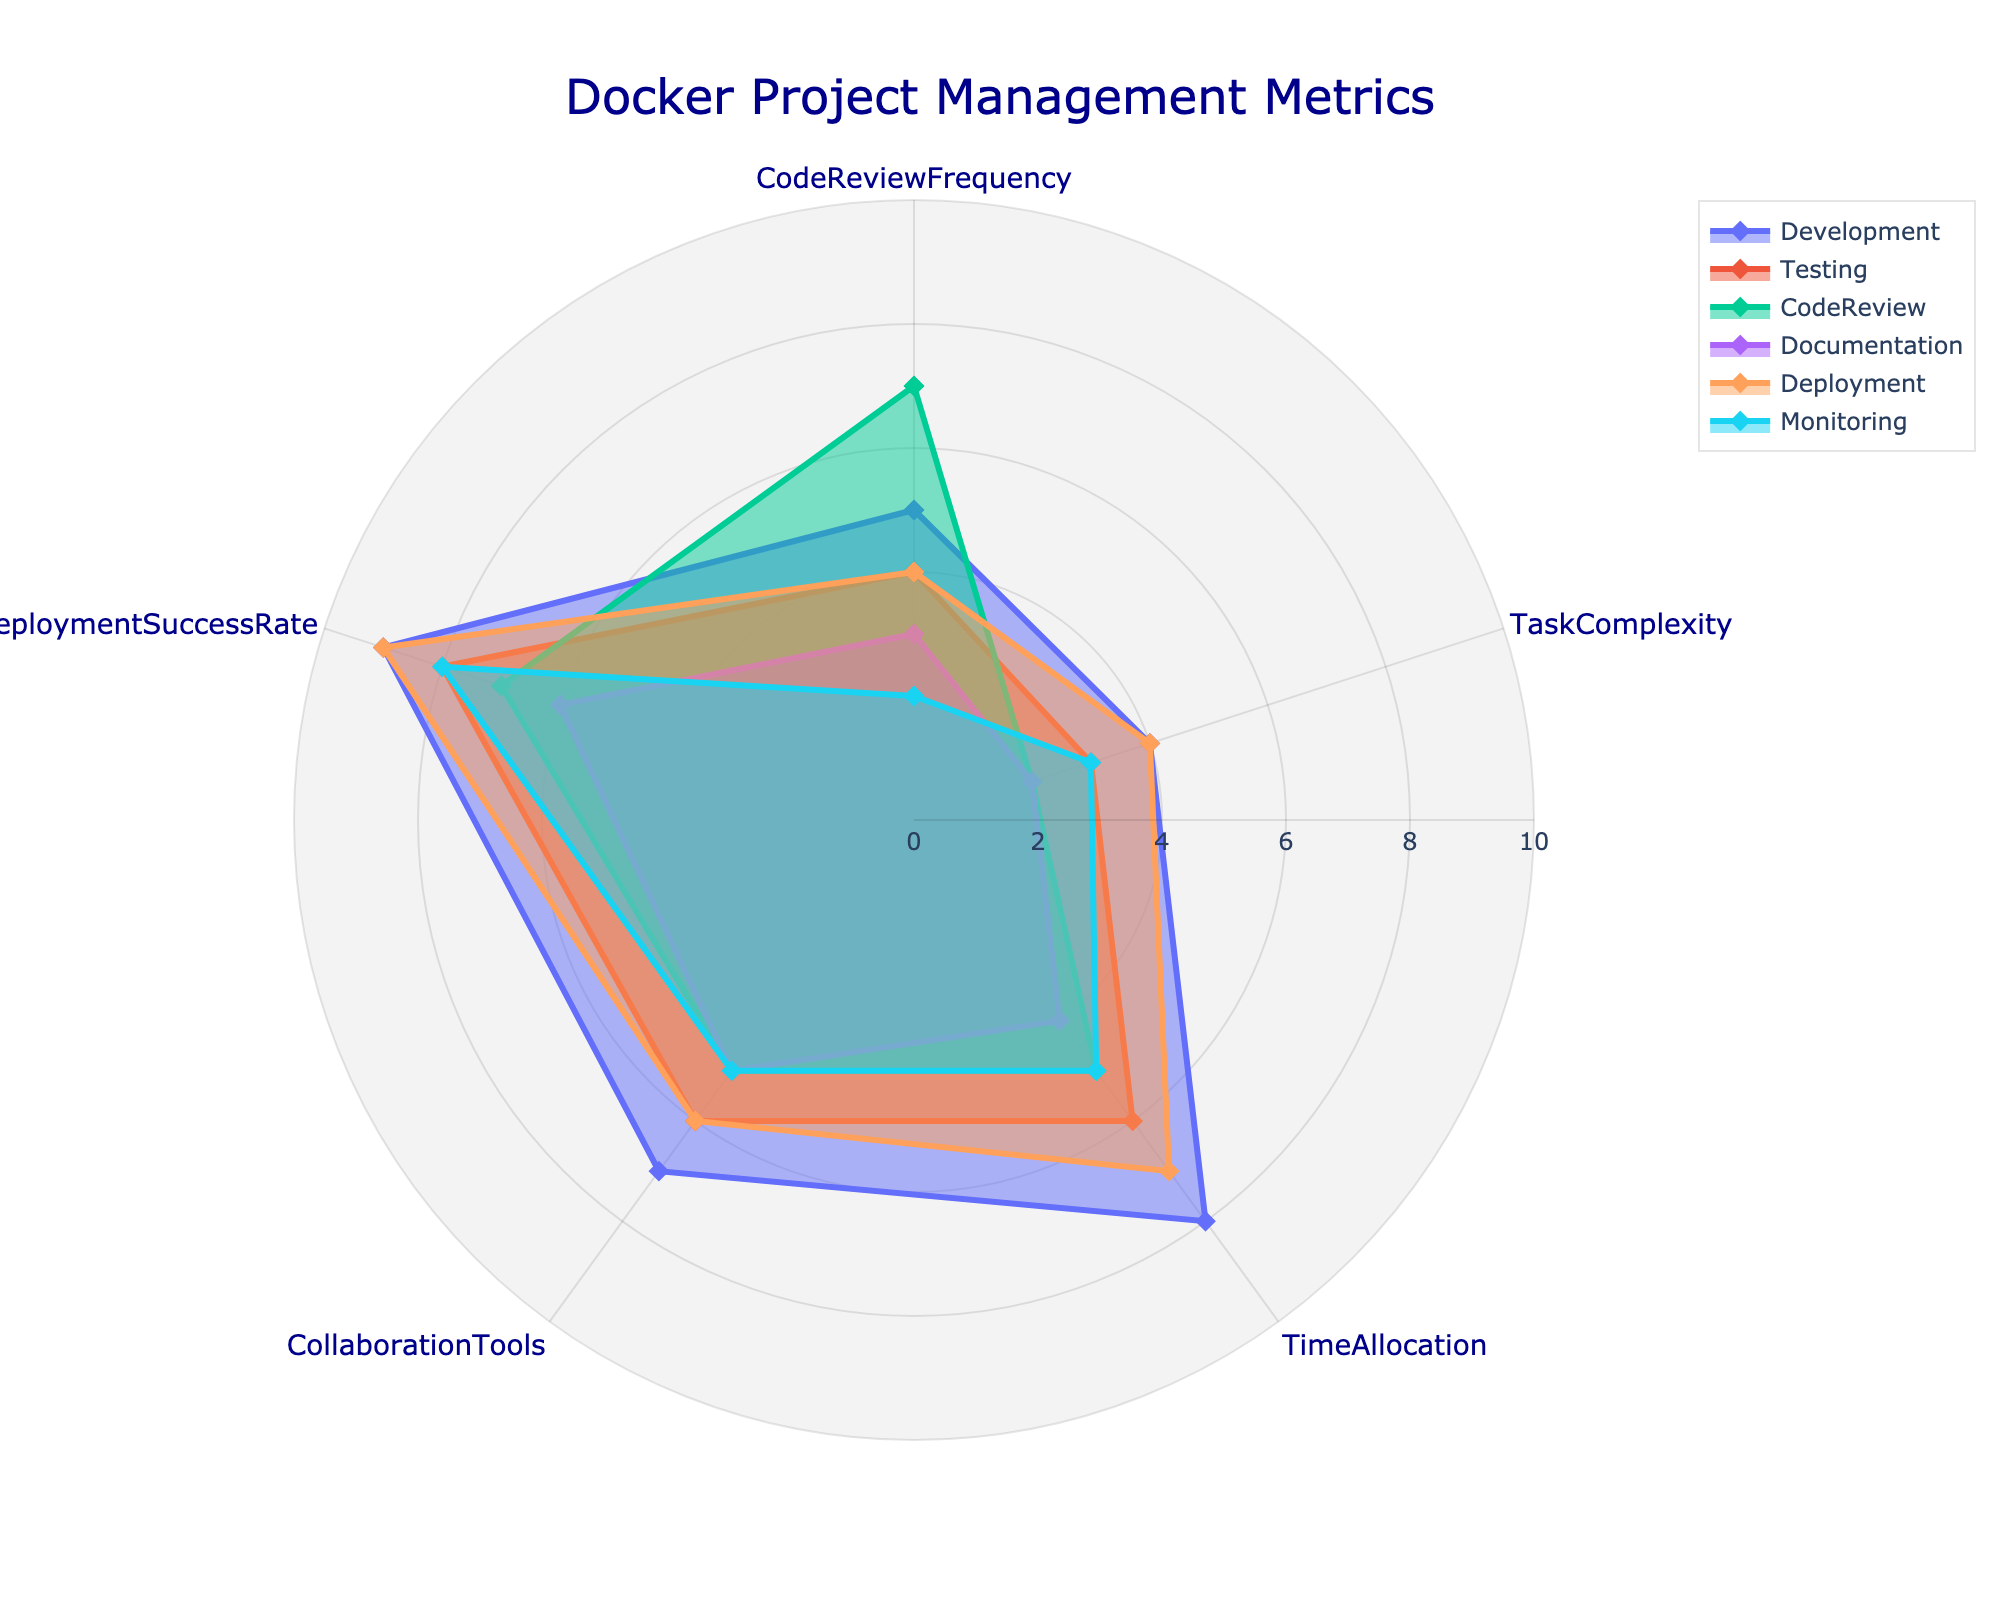What is the title of the figure? The title is usually found at the top of the figure, often larger and in a distinct color, in this case, "Docker Project Management Metrics".
Answer: Docker Project Management Metrics Which category shows the highest value for Deployment Success Rate? Look at the Deployment Success Rates for each category; the 'Development' category has the highest value at 9.
Answer: Development How does the Time Allocation for Development compare to Documentation? The Time Allocation for Development is 8, while for Documentation, it is 4. 8 is greater than 4, so Development has a higher time allocation.
Answer: Development has higher time allocation What are the average values for Task Complexity across all categories? Sum up the Task Complexity values, then divide by the number of categories: (4+3+2+2+4+3)/6 = 18/6 = 3
Answer: 3 In which metric does 'CodeReview' score the highest, and what is the value? Check all the metrics for 'CodeReview'; it scores the highest in Code Review Frequency with a value of 7.
Answer: Code Review Frequency, 7 What is the maximum value for the CodeReviewFrequency metric, and which category does it belong to? The maximum value for CodeReviewFrequency is 7, which belongs to the 'CodeReview' category.
Answer: 7, CodeReview Which category has the lowest score for Collaboration Tools, and what is it? Monitoring has the lowest score for Collaboration Tools with a value of 5.
Answer: Monitoring, 5 Among the following pairs, which category has the higher Task Complexity: Testing or Monitoring? Compare the Task Complexity values for Testing (3) and Monitoring (3); both are equal.
Answer: They are equal How does the Deployment value of Documentation compare to its Time Allocation value? For Documentation, Deployment is 6 and Time Allocation is 4. Deployment (6) is higher than Time Allocation (4).
Answer: Deployment is higher What is the range of the radial axis in the radar chart? The radial axis range is visible on the chart, starting from 0 and going up to 10.
Answer: 0 to 10 